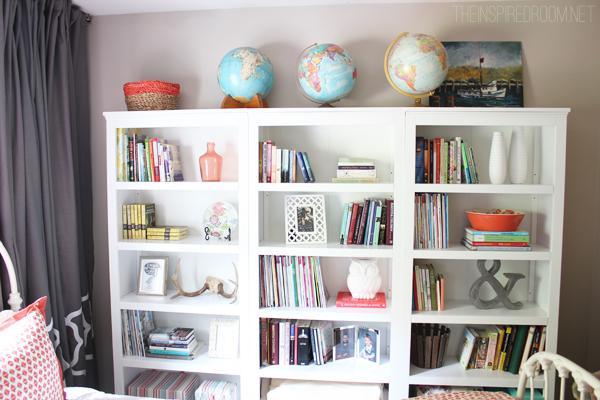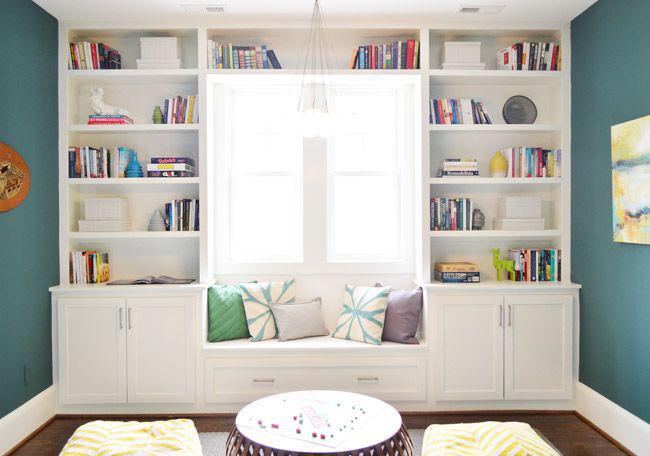The first image is the image on the left, the second image is the image on the right. Evaluate the accuracy of this statement regarding the images: "There is an office chair in front of a desk that has four drawers.". Is it true? Answer yes or no. No. The first image is the image on the left, the second image is the image on the right. Assess this claim about the two images: "At least three pillows are in a window seat in one of the images.". Correct or not? Answer yes or no. Yes. 